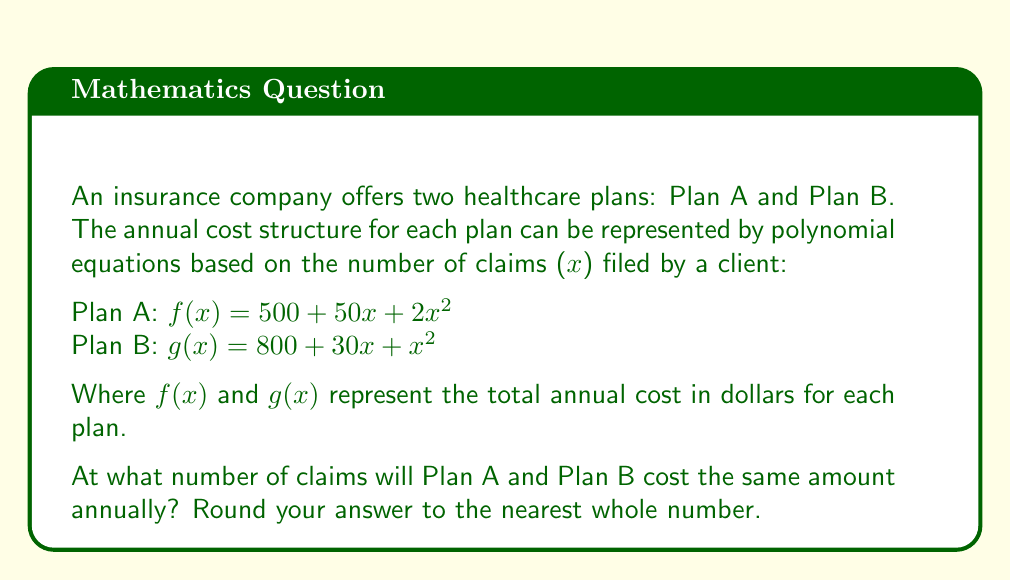Can you answer this question? To find the number of claims where both plans cost the same, we need to set the equations equal to each other and solve for $x$:

$$f(x) = g(x)$$
$$500 + 50x + 2x^2 = 800 + 30x + x^2$$

Simplify by subtracting $500$ from both sides:
$$50x + 2x^2 = 300 + 30x + x^2$$

Subtract $30x$ and $x^2$ from both sides:
$$20x + x^2 = 300$$

Rearrange to standard form:
$$x^2 + 20x - 300 = 0$$

This is a quadratic equation. We can solve it using the quadratic formula:
$$x = \frac{-b \pm \sqrt{b^2 - 4ac}}{2a}$$

Where $a = 1$, $b = 20$, and $c = -300$

$$x = \frac{-20 \pm \sqrt{20^2 - 4(1)(-300)}}{2(1)}$$
$$x = \frac{-20 \pm \sqrt{400 + 1200}}{2}$$
$$x = \frac{-20 \pm \sqrt{1600}}{2}$$
$$x = \frac{-20 \pm 40}{2}$$

This gives us two solutions:
$$x = \frac{-20 + 40}{2} = 10$$ or $$x = \frac{-20 - 40}{2} = -30$$

Since the number of claims cannot be negative, we discard the negative solution.

Therefore, Plan A and Plan B will cost the same amount when a client files 10 claims annually.
Answer: 10 claims 